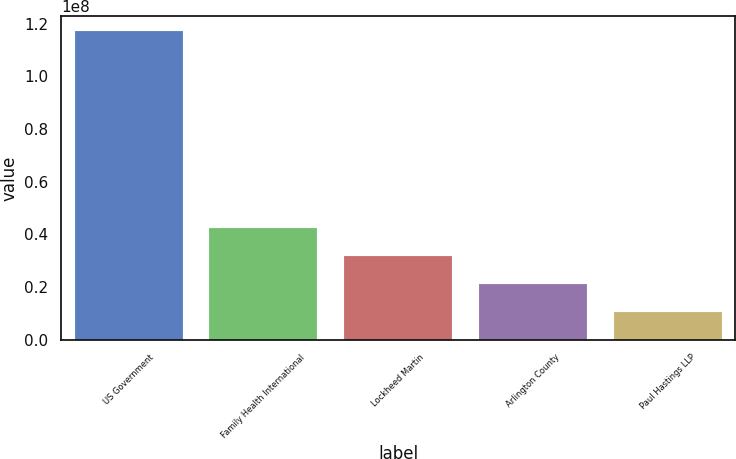Convert chart. <chart><loc_0><loc_0><loc_500><loc_500><bar_chart><fcel>US Government<fcel>Family Health International<fcel>Lockheed Martin<fcel>Arlington County<fcel>Paul Hastings LLP<nl><fcel>1.17035e+08<fcel>4.25522e+07<fcel>3.19118e+07<fcel>2.12714e+07<fcel>1.0631e+07<nl></chart> 